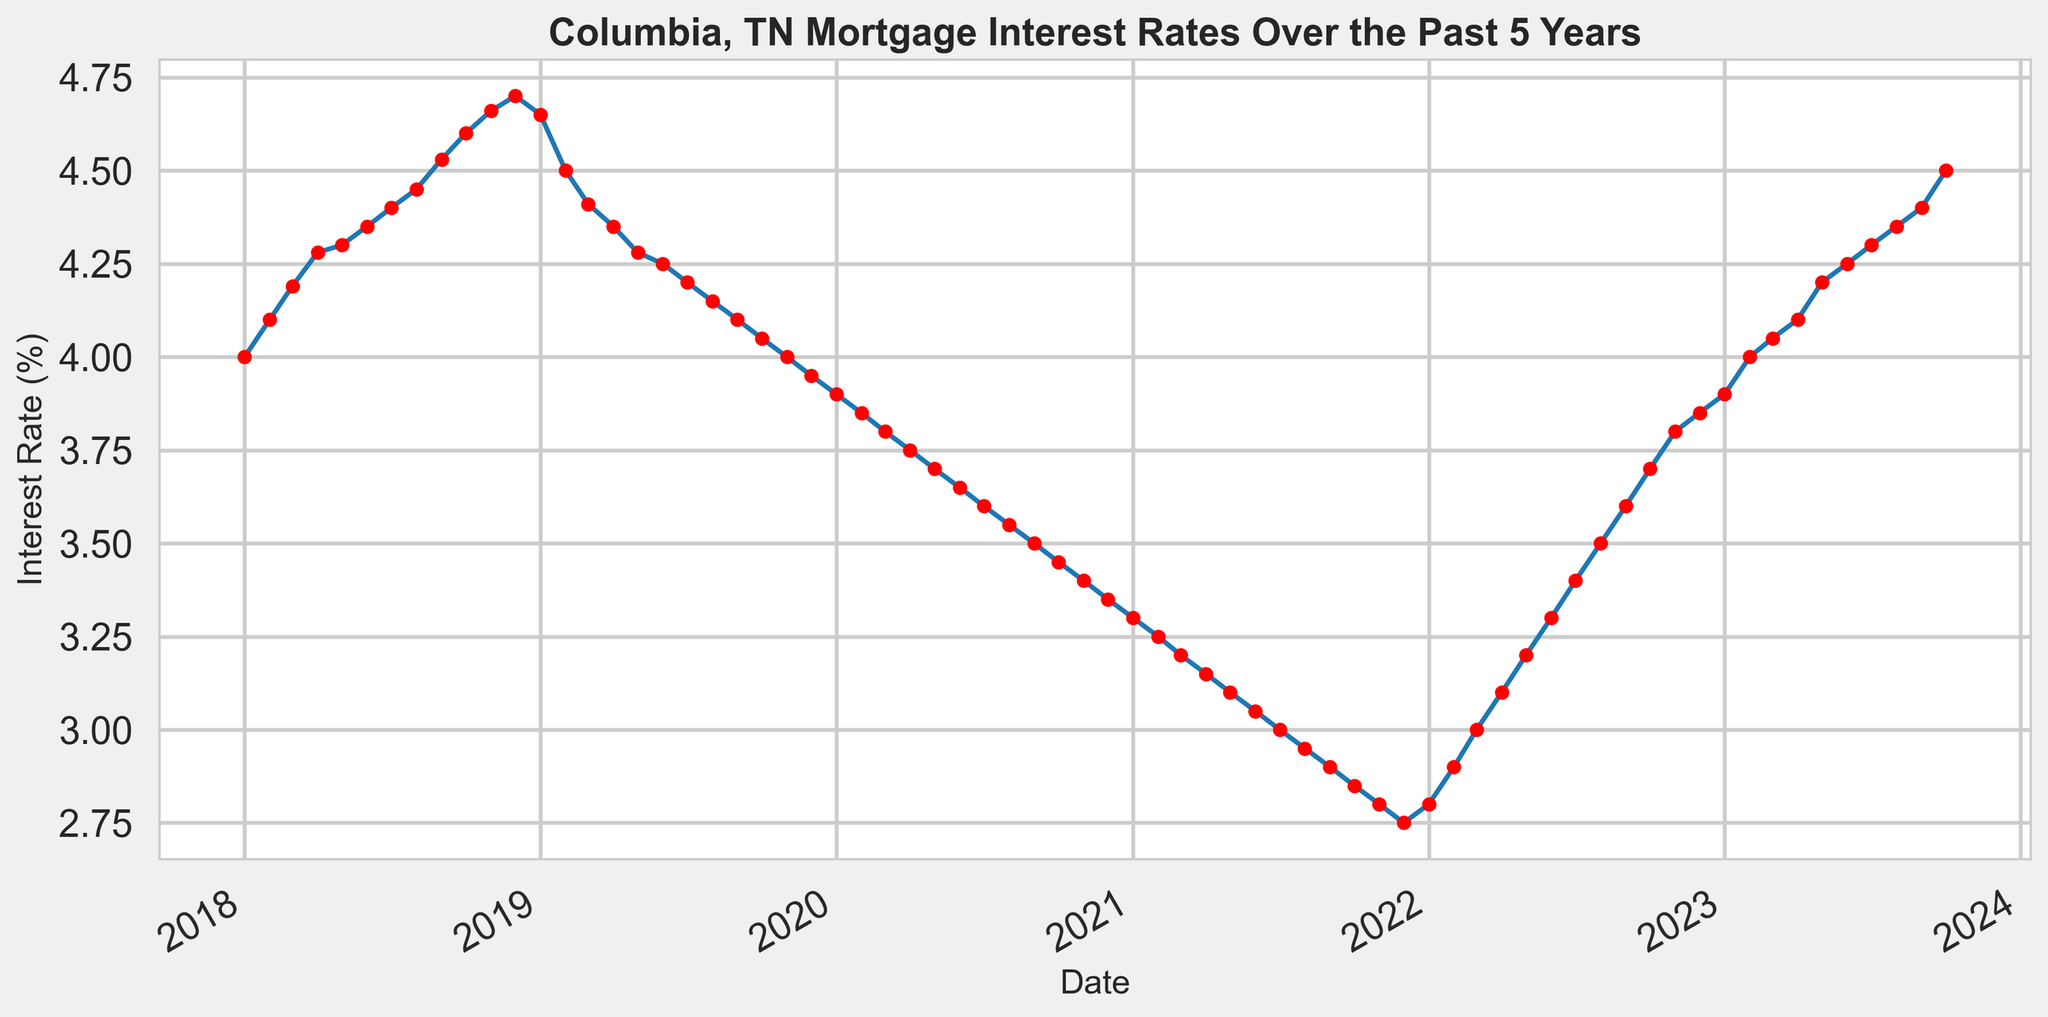What was the highest mortgage interest rate recorded over the past 5 years? To find the highest interest rate, look at the y-axis values and identify the peak point on the line chart. The highest point on the line chart corresponds to an interest rate of 4.70%.
Answer: 4.70% What was the lowest mortgage interest rate recorded during the past 5 years? To find the lowest interest rate, look at the y-axis values and identify the lowest point on the line chart. The lowest point on the line chart corresponds to an interest rate of 2.75%.
Answer: 2.75% By how much did the mortgage interest rate change from January 2021 to October 2021? Look at the values for January 2021 (3.30%) and October 2021 (2.85%), then subtract the latter from the former. The change is 3.30% - 2.85% = 0.45%.
Answer: 0.45% During which period did the mortgage interest rate consistently decrease, and what was the total decrease during that period? Look for a continuous downward trend in the line chart and measure the difference between the starting and ending values of that period. From December 2018 (4.70%) to December 2019 (3.95%), there is a consistent decrease, and the total decrease is 4.70% - 3.95% = 0.75%.
Answer: December 2018 to December 2019, 0.75% How much did the mortgage interest rate increase from November 2021 to October 2023? Check the values for November 2021 (2.80%) and October 2023 (4.50%), then subtract the former from the latter. The increase is 4.50% - 2.80% = 1.70%.
Answer: 1.70% Compare the mortgage interest rate in January 2020 and January 2023. Which year had a higher rate, and by how much? Look at the values for January 2020 (3.90%) and January 2023 (3.90%), and compare them. Both years have the same mortgage interest rate.
Answer: Same, 0% What was the average mortgage interest rate in 2022? Extract the interest rates for each month in 2022, add them up, and divide by the number of months (12). The average rate is (2.80% + 2.90% + 3.00% + 3.10% + 3.20% + 3.30% + 3.40% + 3.50% + 3.60% + 3.70% + 3.80% + 3.85%) / 12 = 3.35%.
Answer: 3.35% Around which month and year did the mortgage interest rate hit its lowest point? Observe the lowest point on the line chart and note the corresponding month and year labeled on the x-axis. The lowest point is around November 2021.
Answer: November 2021 